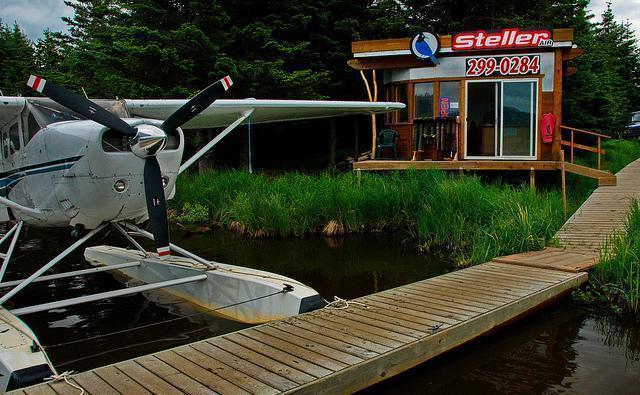What rhymes with the name of the store and is found on the vehicle?
Pick the correct solution from the four options below to address the question.
Options: Trunk, hood, door, propeller. Propeller. 